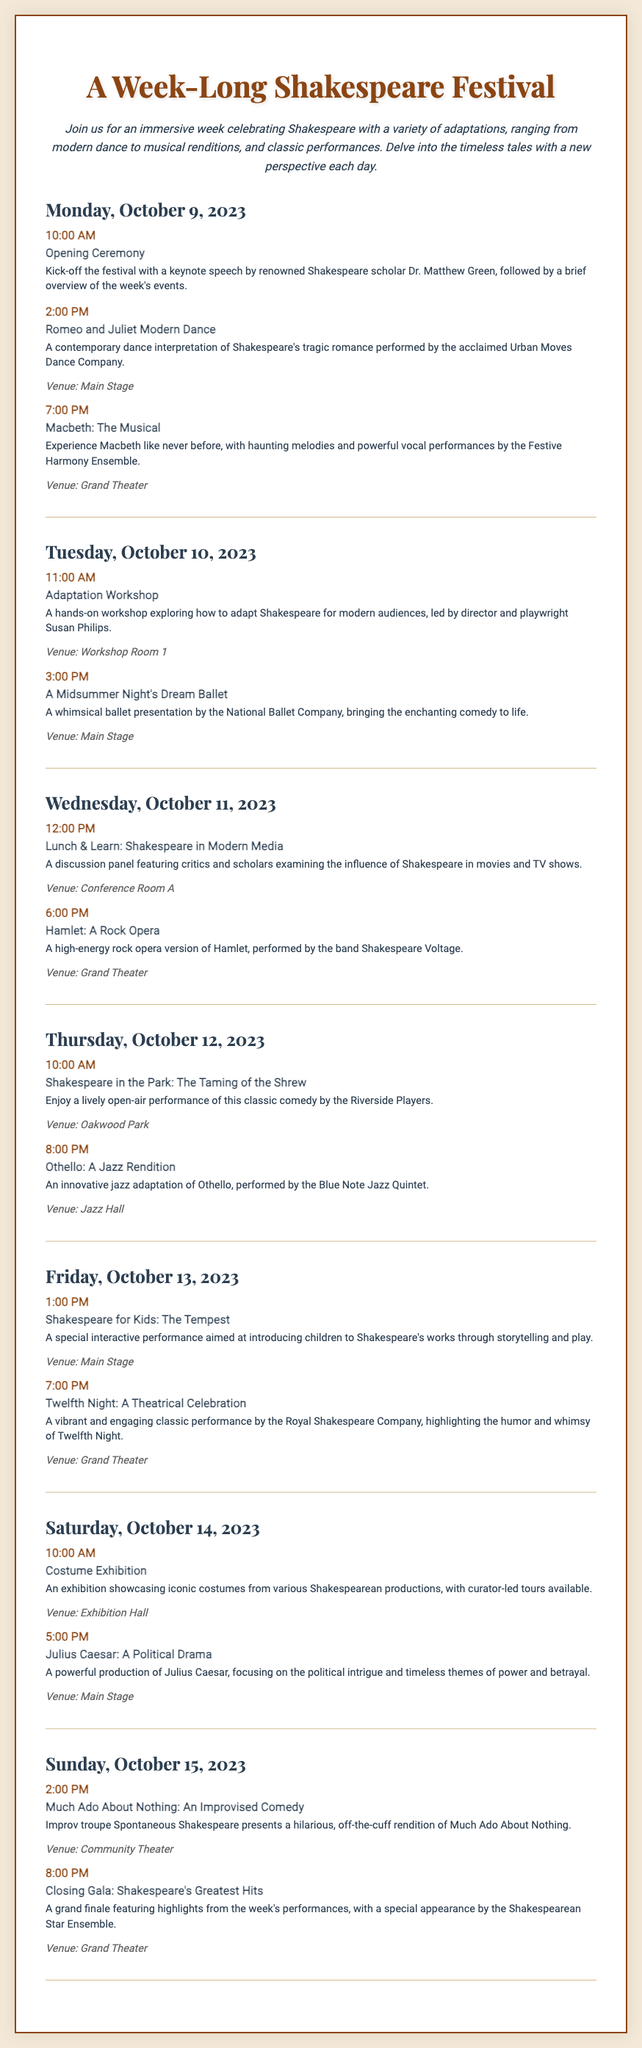What is the opening event of the festival? The opening event is described as the "Opening Ceremony" scheduled for 10:00 AM on Monday.
Answer: Opening Ceremony Who is the keynote speaker at the opening ceremony? The keynote speaker is mentioned as Dr. Matthew Green, a renowned Shakespeare scholar.
Answer: Dr. Matthew Green What time does "Romeo and Juliet Modern Dance" start? The starting time for "Romeo and Juliet Modern Dance" is provided as 2:00 PM on Monday.
Answer: 2:00 PM On which day is the "Lunch & Learn: Shakespeare in Modern Media" scheduled? The event is scheduled for Wednesday, October 11, 2023, at 12:00 PM.
Answer: Wednesday, October 11, 2023 What type of performance is "Hamlet: A Rock Opera"? The performance is characterized as a high-energy rock opera version of Hamlet.
Answer: Rock Opera Which venue will host the "Shakespeare for Kids: The Tempest"? The venue for "Shakespeare for Kids: The Tempest" is identified as the Main Stage.
Answer: Main Stage How many events are scheduled for Friday? The document lists two events occurring on Friday, October 13, 2023.
Answer: Two What is the focus of "Julius Caesar: A Political Drama"? The focus is described as political intrigue and timeless themes of power and betrayal.
Answer: Political intrigue and timeless themes of power and betrayal What type of adaptation is presented in "Othello: A Jazz Rendition"? The adaptation of Othello is specifically mentioned as innovative jazz.
Answer: Jazz When does the festival close? The festival closes with the "Closing Gala: Shakespeare's Greatest Hits" scheduled for 8:00 PM on Sunday.
Answer: 8:00 PM on Sunday 